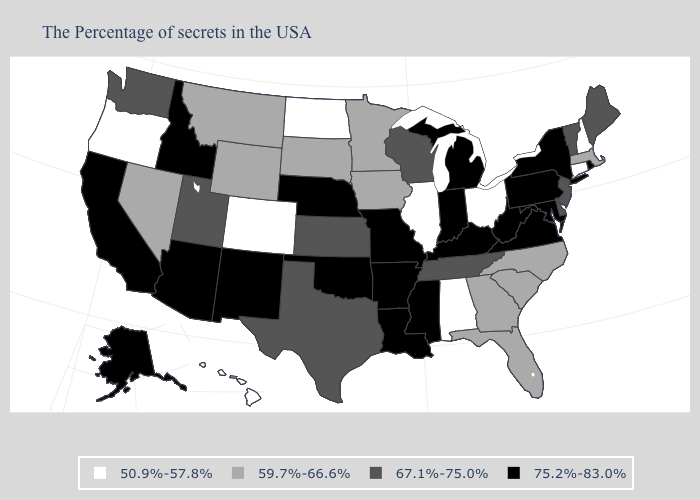What is the value of Hawaii?
Keep it brief. 50.9%-57.8%. What is the value of Wisconsin?
Concise answer only. 67.1%-75.0%. Which states have the lowest value in the Northeast?
Keep it brief. New Hampshire, Connecticut. Does Arizona have the lowest value in the West?
Be succinct. No. What is the value of Pennsylvania?
Keep it brief. 75.2%-83.0%. Among the states that border Mississippi , which have the highest value?
Give a very brief answer. Louisiana, Arkansas. What is the lowest value in the West?
Give a very brief answer. 50.9%-57.8%. What is the value of South Carolina?
Concise answer only. 59.7%-66.6%. What is the highest value in states that border Kentucky?
Keep it brief. 75.2%-83.0%. Does Massachusetts have the highest value in the USA?
Quick response, please. No. Name the states that have a value in the range 50.9%-57.8%?
Give a very brief answer. New Hampshire, Connecticut, Ohio, Alabama, Illinois, North Dakota, Colorado, Oregon, Hawaii. Name the states that have a value in the range 59.7%-66.6%?
Quick response, please. Massachusetts, North Carolina, South Carolina, Florida, Georgia, Minnesota, Iowa, South Dakota, Wyoming, Montana, Nevada. Does Oregon have the lowest value in the USA?
Concise answer only. Yes. 